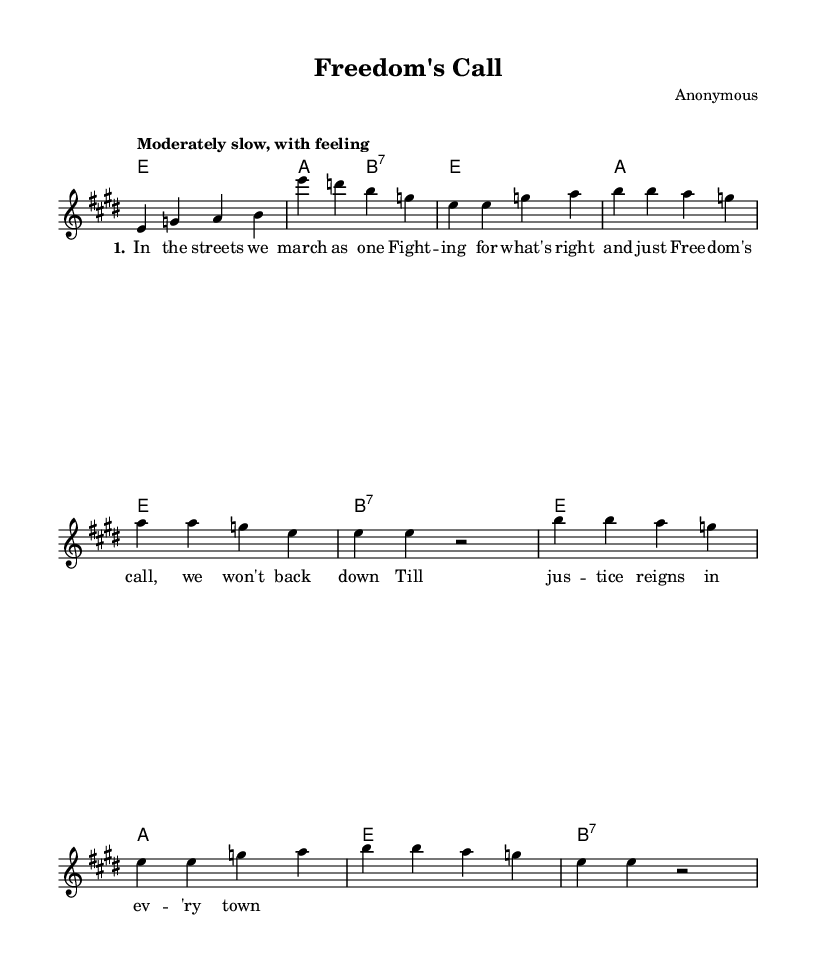What is the key signature of this music? The key is E major, which has four sharps indicated in the key signature section of the sheet music.
Answer: E major What is the time signature of this piece? The time signature is shown as 4/4 at the beginning of the score, indicating four beats per measure.
Answer: 4/4 What is the tempo marking for this piece? The tempo marking is "Moderately slow, with feeling," which suggests a relaxed and expressive pace.
Answer: Moderately slow, with feeling How many verses are in this song? The lyrics section indicates that there is one verse followed by the chorus, implying one verse exists in this piece.
Answer: 1 What type of musical form is evident in this anthem? The structure follows a verse-chorus form, which is typical in protest anthems, alternating between lyrical content and repeated choruses.
Answer: Verse-chorus Which chord is played after the chorus in this piece? The chord following the chorus is indicated as B7, which is used as a dominant seventh chord resolving typically to E major in blues music.
Answer: B7 What is the title of the piece? The title is mentioned at the top of the sheet music under the header section as "Freedom's Call," indicating its thematic focus.
Answer: Freedom's Call 